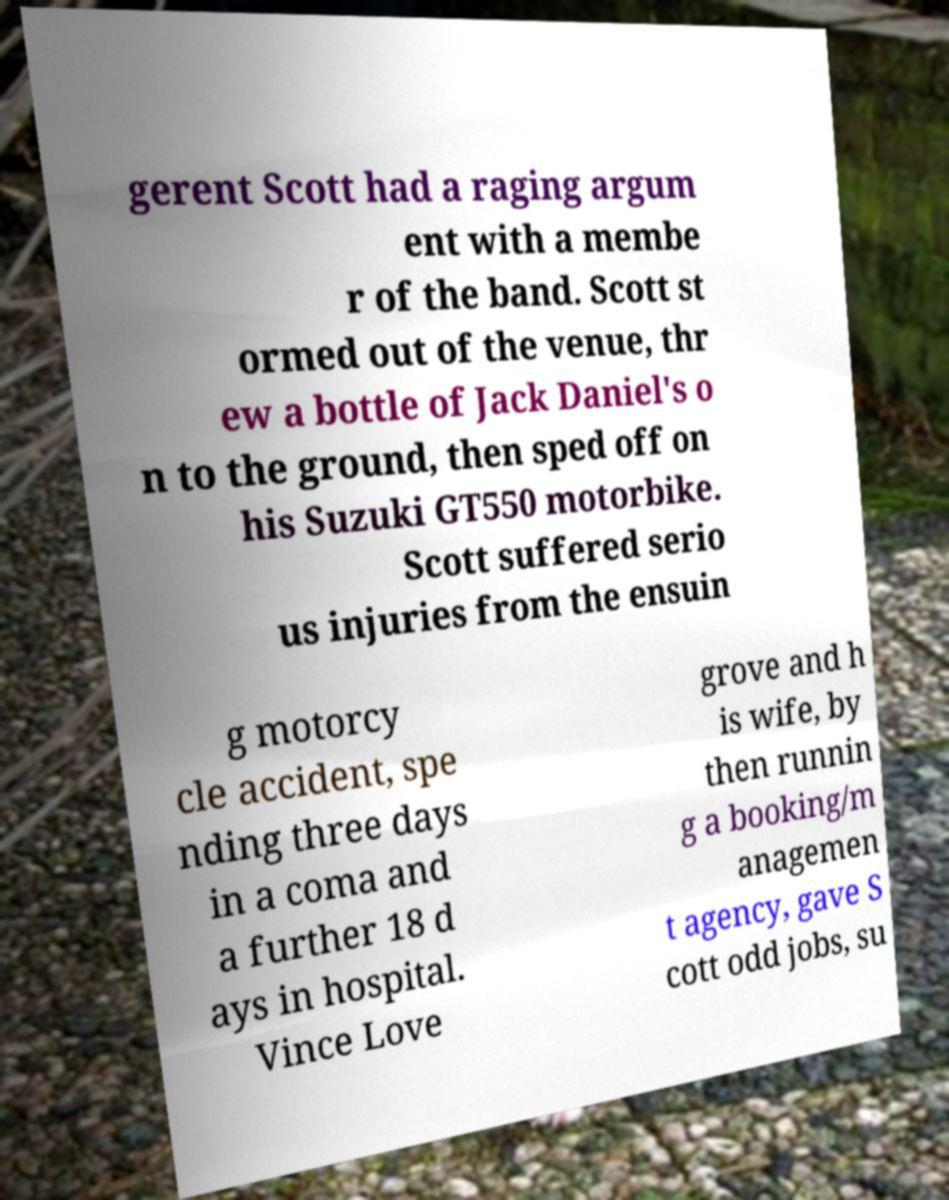Could you assist in decoding the text presented in this image and type it out clearly? gerent Scott had a raging argum ent with a membe r of the band. Scott st ormed out of the venue, thr ew a bottle of Jack Daniel's o n to the ground, then sped off on his Suzuki GT550 motorbike. Scott suffered serio us injuries from the ensuin g motorcy cle accident, spe nding three days in a coma and a further 18 d ays in hospital. Vince Love grove and h is wife, by then runnin g a booking/m anagemen t agency, gave S cott odd jobs, su 